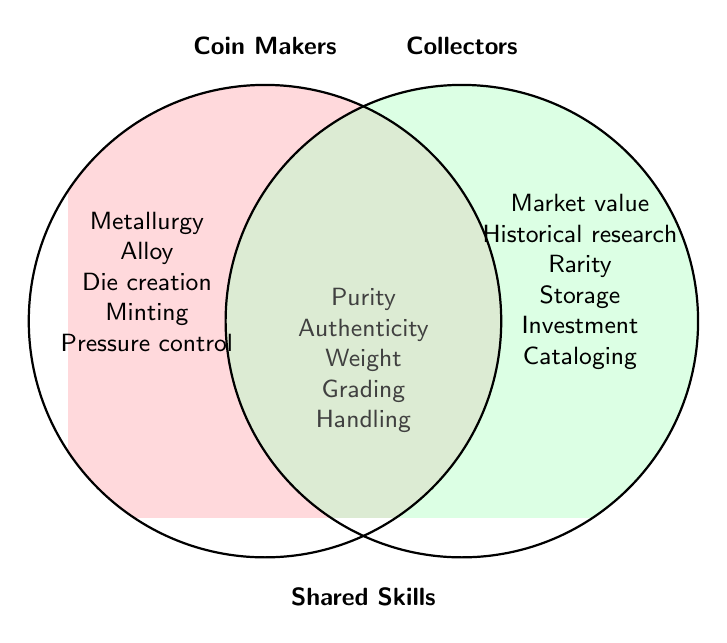How many exclusive skills do Coin Makers have? The figure lists the exclusive skills of Coin Makers outside of the overlap area in their own section. Counting these skills, we have Metallurgy knowledge, Alloy composition expertise, Die creation skills, Minting techniques, and Pressure control.
Answer: 5 How many exclusive skills do Collectors have? The figure lists the exclusive skills of Collectors outside of the overlap area in their own section. Counting these skills, we have Market value assessment, Historical research, Rarity evaluation, Storage methods, Investment strategies, and Cataloging systems.
Answer: 6 How many shared skills are there between Coin Makers and Collectors? The figure lists the shared skills in the overlap area. Counting these, we have Purity verification, Authenticity determination, Weight measurement, Grading proficiency, and Handling techniques.
Answer: 5 Which group has more exclusive skills? Coin Makers have 5 exclusive skills and Collectors have 6 exclusive skills. Comparing these, Collectors have more exclusive skills.
Answer: Collectors Are authenticity determination skills specific to Coin Makers, Collectors, or shared? The figure places authenticity determination within the overlap area, which indicates it is a shared skill between Coin Makers and Collectors.
Answer: Shared How many skills in total are mentioned in the figure? To find the total number of skills, count all the exclusive and shared skills: (5 exclusive skills of Coin Makers) + (6 exclusive skills of Collectors) + (5 shared skills) = 5 + 6 + 5.
Answer: 16 Which shared skill is related to verifying precision? From the shared skills listed, Weight measurement relates to verifying precision.
Answer: Weight measurement Between Metallurgy knowledge and Cataloging systems, which is exclusive to Coin Makers? By observing the non-overlapping sections, Metallurgy knowledge is in the Coin Makers' section, while Cataloging systems are in the Collectors' section. Thus, Metallurgy knowledge is exclusive to Coin Makers.
Answer: Metallurgy knowledge 